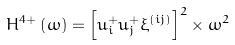Convert formula to latex. <formula><loc_0><loc_0><loc_500><loc_500>H ^ { 4 + } \left ( \omega \right ) = \left [ u _ { i } ^ { + } u _ { j } ^ { + } \xi ^ { \left ( i j \right ) } \right ] ^ { 2 } \times \omega ^ { 2 }</formula> 